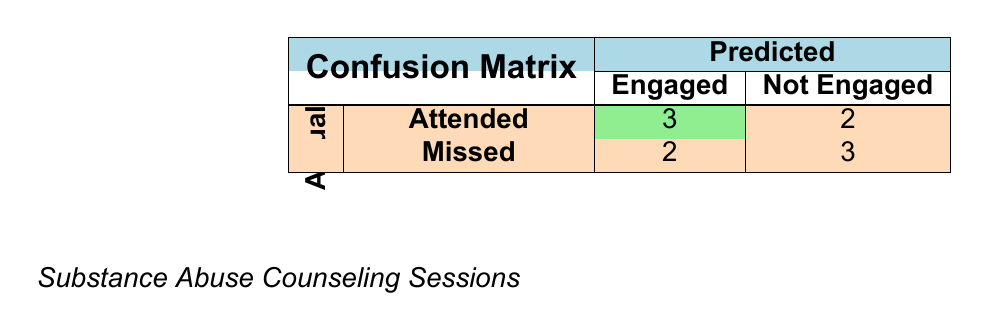What is the total number of clients who attended their appointments? According to the table, the clients who attended (engaged) are represented in the "Attended" row, showing a total of 3 engaged clients.
Answer: 3 How many clients missed their appointments and were not engaged? To answer this, we look at the "Missed" row under "Not Engaged." There are 3 clients listed there, which means 3 clients missed their appointments and were not engaged.
Answer: 3 What is the total number of clients in the study? The total number of clients is the sum of clients in each category. From the table, we have 3 who attended and were engaged, 2 who attended and were not engaged, 2 who missed and were engaged, and 3 who missed and were not engaged. Adding these together gives 3 + 2 + 2 + 3 = 10 clients.
Answer: 10 Is it true that more clients attended their appointments than missed them? To find this out, we compare the number of clients who attended (5 clients: 3 engaged + 2 not engaged) versus those who missed (5 clients: 2 engaged + 3 not engaged). Since both numbers are equal, the statement is false.
Answer: No What percentage of clients who missed their appointments were successfully engaged? There are a total of 5 clients who missed appointments (2 who were engaged and 3 who were not). Therefore, the percentage of those who were engaged is (2 engaged / 5 total missed) * 100 = 40%.
Answer: 40% If a client misses an appointment, what is the probability of being successfully engaged in therapy? Among the 5 clients who missed their appointments, 2 were successfully engaged. Therefore, the probability is calculated as 2 engaged / 5 missed = 0.4 or 40%.
Answer: 40% How many clients were successfully engaged after attending their appointment? According to the table, there were 3 clients who attended their appointments and were successfully engaged.
Answer: 3 What is the ratio of missed appointments among successful engagements? To find the ratio, we look at the number of missed appointments (5) compared to successful engagements (5). So, the ratio is 5:5, simplifying to 1:1.
Answer: 1:1 What can we deduce about clients who missed their appointments regarding their engagement in counseling? From the table, we see that out of 5 clients who missed their appointments, 2 were engaged and 3 were not. This indicates that missing appointments does not necessarily equate to a lack of engagement, but it's a strong factor.
Answer: Missing appointments impacts engagement 